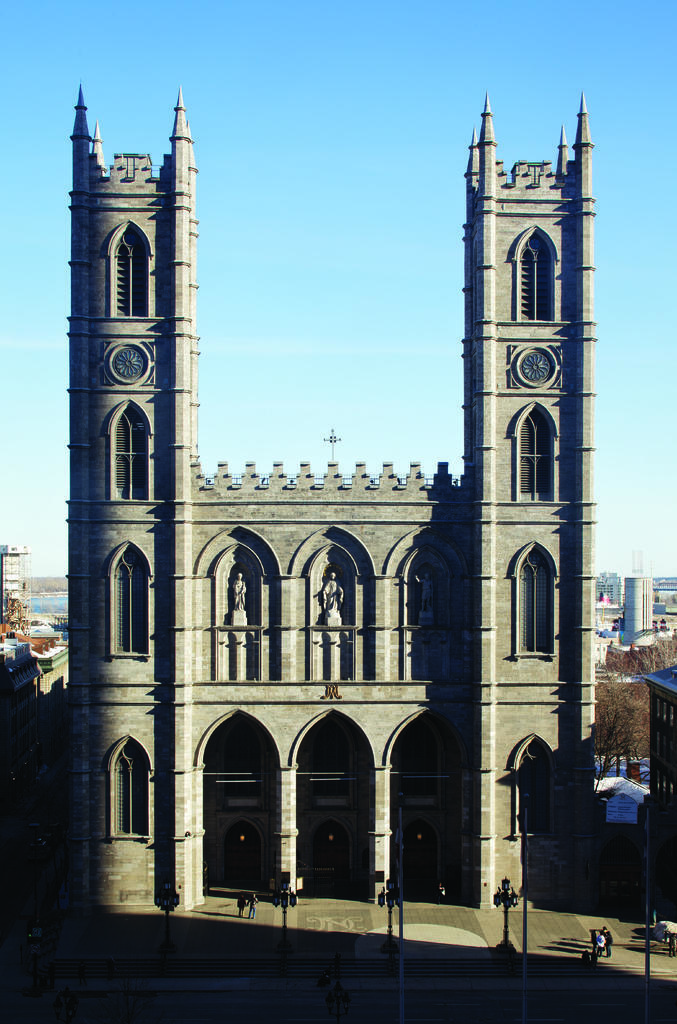What is the main subject in the middle of the picture? There is a monument in the middle of the picture. What can be seen in the background of the picture? There is sky visible in the background of the picture. What type of sound can be heard coming from the monument in the image? There is no sound present in the image, as it is a still photograph. 